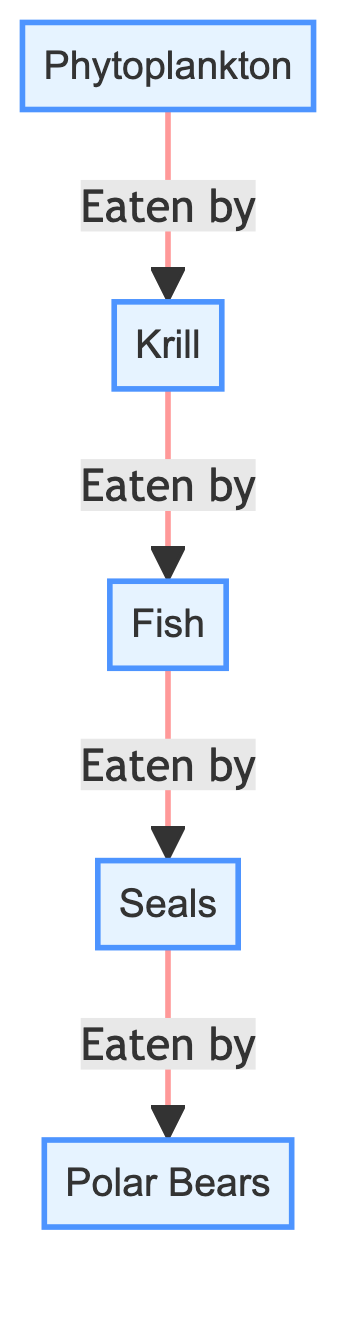What is the first organism in the food chain? The first organism listed in the diagram is "Phytoplankton," which is the starting point for the food chain as it generates energy for the subsequent organisms.
Answer: Phytoplankton How many organisms are in the food chain? There are five organisms shown in the diagram: Phytoplankton, Krill, Fish, Seals, and Polar Bears. Counting these organisms provides the total number of nodes.
Answer: 5 What is the last organism in the food chain? The last organism in the food chain, according to the directional flow of energy, is "Polar Bears," which is the top predator in the chain.
Answer: Polar Bears Who eats Krill? Based on the diagram, "Fish" is the organism that consumes Krill, as indicated by the directional arrow pointing from Krill to Fish.
Answer: Fish How many levels are there in the food chain? The food chain consists of four trophic levels: Primary producers (Phytoplankton), Primary consumers (Krill), Secondary consumers (Fish), and Tertiary consumers (Seals and Polar Bears). Counting these nodes provides the total number of levels.
Answer: 4 What relationship do Seals have with Fish in the diagram? The diagram shows that Seals have a predatory relationship with Fish, as indicated by the arrow pointing from Fish to Seals, meaning Fish are eaten by Seals.
Answer: Eaten by If Phytoplankton population declines, what can be inferred about the rest of the food chain? A decline in Phytoplankton would reduce food availability for Krill, which would then affect Fish populations due to lower food sources, leading to impacts on Seals and subsequently Polar Bears, thereby cascading down the food chain.
Answer: Negative impact Which organism has the highest position in the food chain? The highest position in the food chain is held by "Polar Bears," as they are the top predator and not eaten by any other organisms in this diagram.
Answer: Polar Bears What organism directly eats Fish? According to the flow in the diagram, "Seals" are the organisms that eat Fish, as indicated by the arrow from Fish to Seals.
Answer: Seals How many predatory relationships are depicted in the diagram? There are four predatory relationships depicted in the diagram, indicated by the arrows showing which organism eats another, specifically from Phytoplankton to Krill, Krill to Fish, Fish to Seals, and Seals to Polar Bears.
Answer: 4 